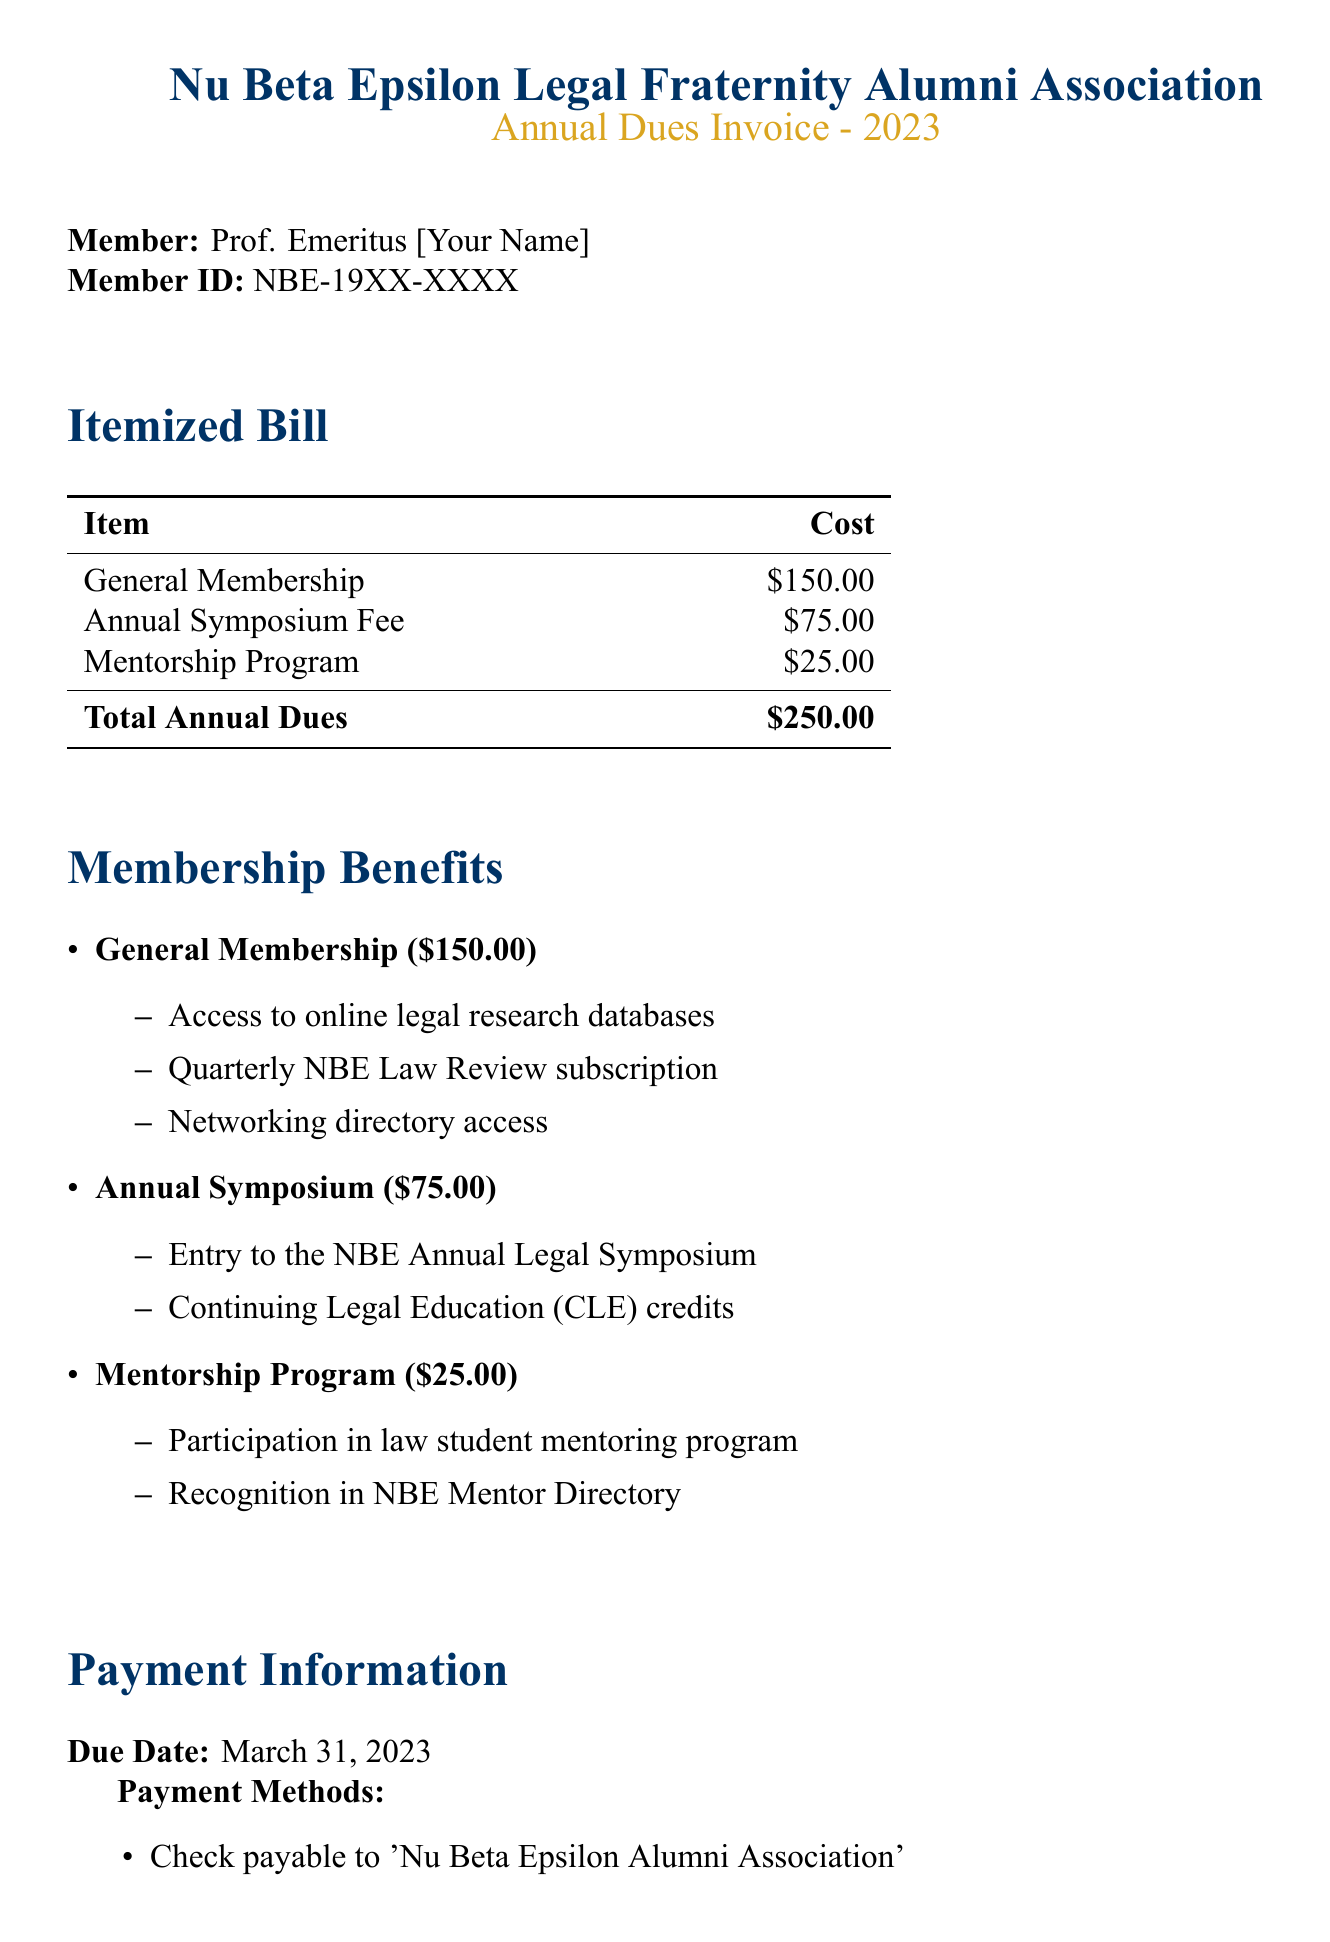What is the membership ID for Prof. Emeritus? The membership ID is listed directly in the document under the member's information.
Answer: NBE-19XX-XXXX What is the cost of the General Membership? The cost is clearly stated in the itemized bill portion of the document.
Answer: $150.00 What date is the payment due? The due date is mentioned in the payment information section of the document.
Answer: March 31, 2023 What is the late fee amount? The late fee is specified in the payment information section with clear expectations for late payments.
Answer: $25.00 What are the benefits of the Annual Symposium? The benefits are outlined in a bullet list under the membership benefits section, highlighting specific features.
Answer: Entry to the NBE Annual Legal Symposium and Continuing Legal Education (CLE) credits What are the accepted payment methods? The document includes a list of methods for making payments in the payment information section.
Answer: Check, Online payment, Credit card by phone How much is the total annual dues? The total is provided in the itemized bill section, which sums up all costs associated with membership.
Answer: $250.00 What is included in the Mentorship Program? The document details items associated with the Mentorship Program under membership benefits.
Answer: Participation in law student mentoring program and recognition in NBE Mentor Directory 